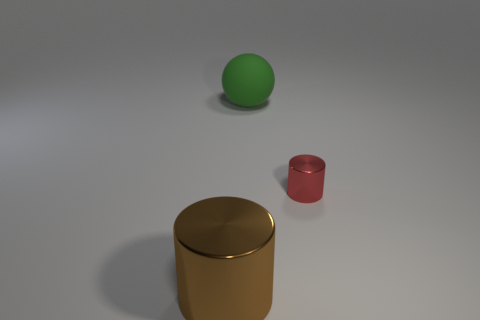What is the thing that is both in front of the big matte thing and to the left of the small object made of? The item located in front of the large matte cylinder and to the left of the small red cylinder appears to be constructed from a type of metal, characterized by its reflective gold surface and solid form. 